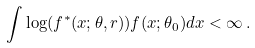<formula> <loc_0><loc_0><loc_500><loc_500>\int \log ( f ^ { \ast } ( x ; \theta , r ) ) f ( x ; \theta _ { 0 } ) d x < \infty \, .</formula> 